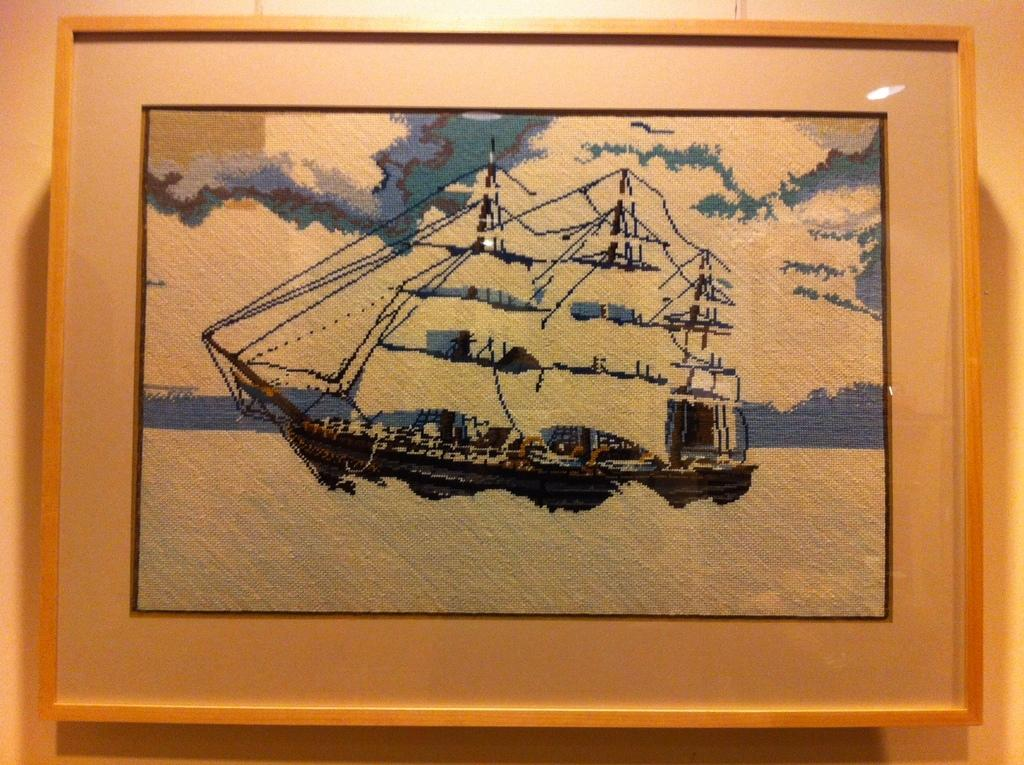What is the main subject of the image? There is an art piece in the image. How is the art piece displayed? The art piece is framed and attached to a wall. What is the theme of the art piece? The art piece depicts a ship. Where is the ship located in the art piece? The ship is in the water. How many bananas are hanging from the rod in the image? There are no bananas or rods present in the image. 